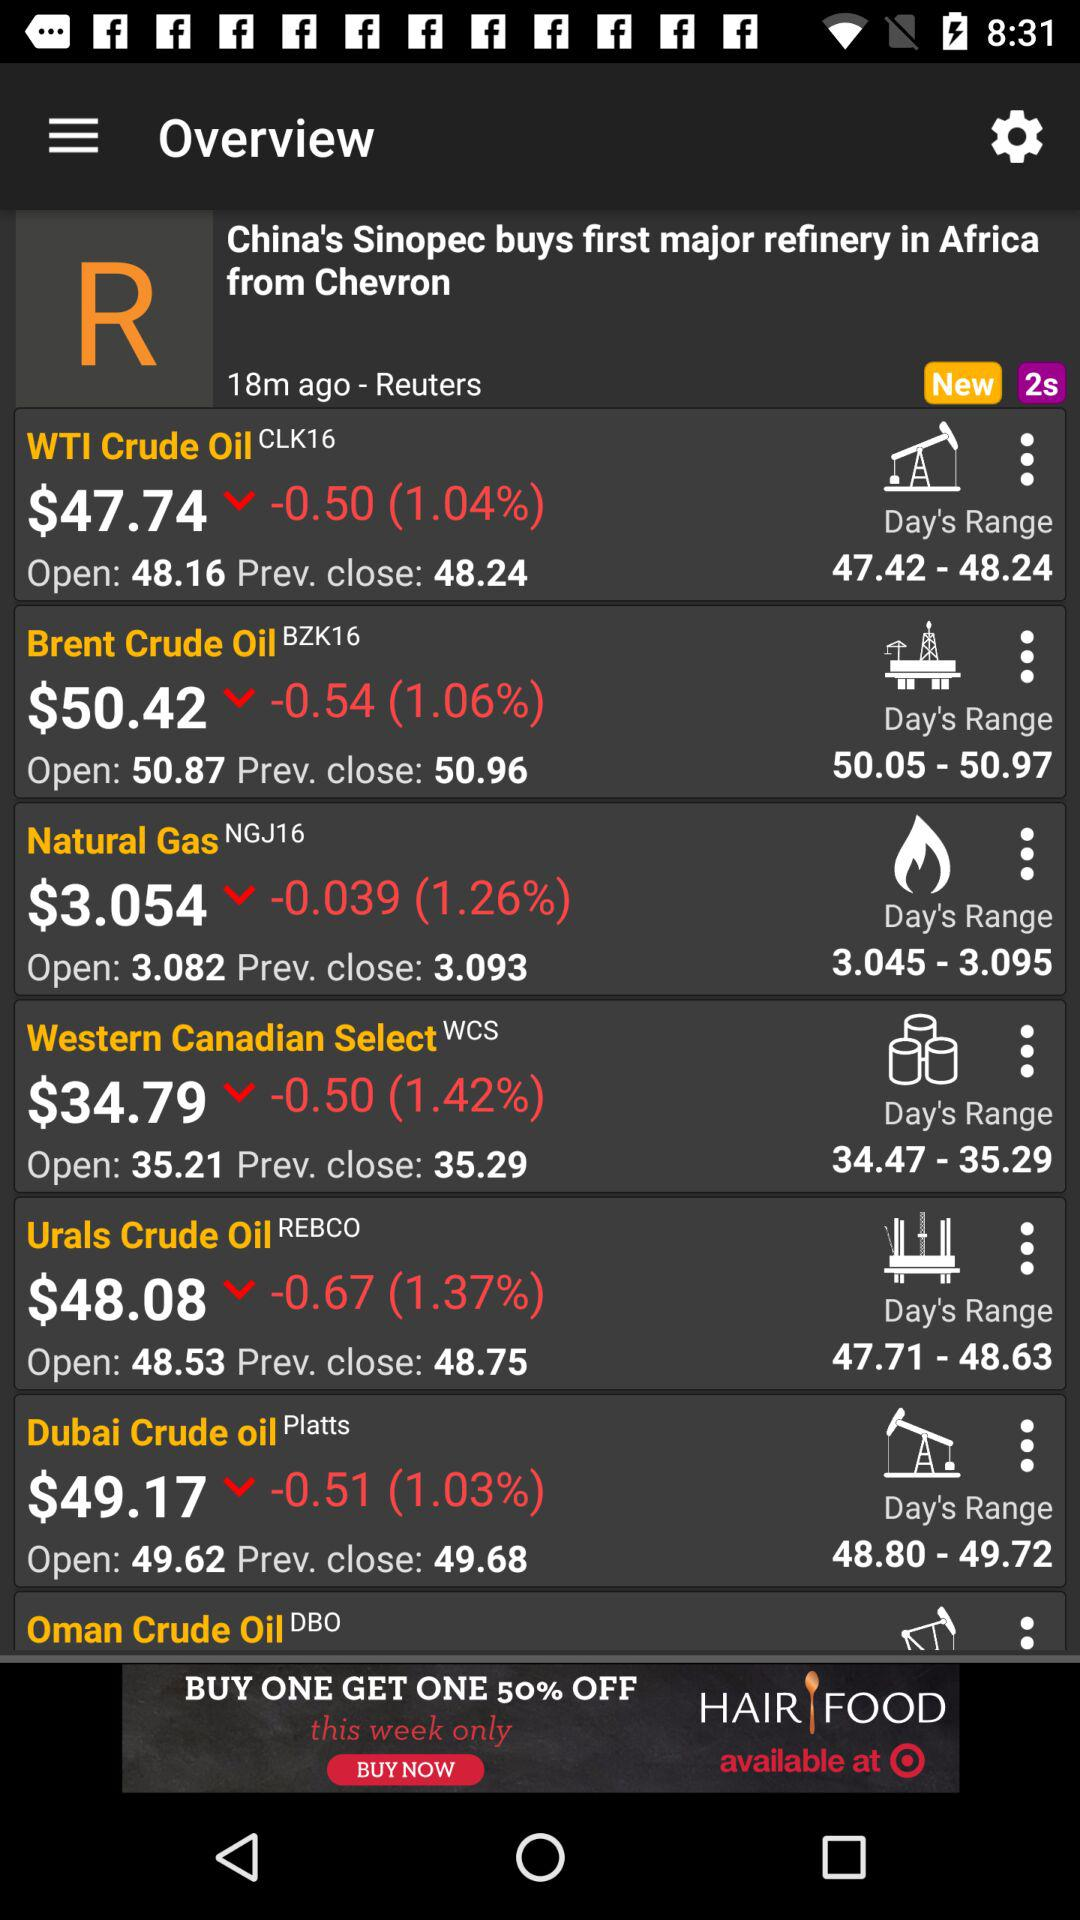What is the price of "Natural Gas" in dollars? The price of "Natural Gas" in dollars is 3.054. 